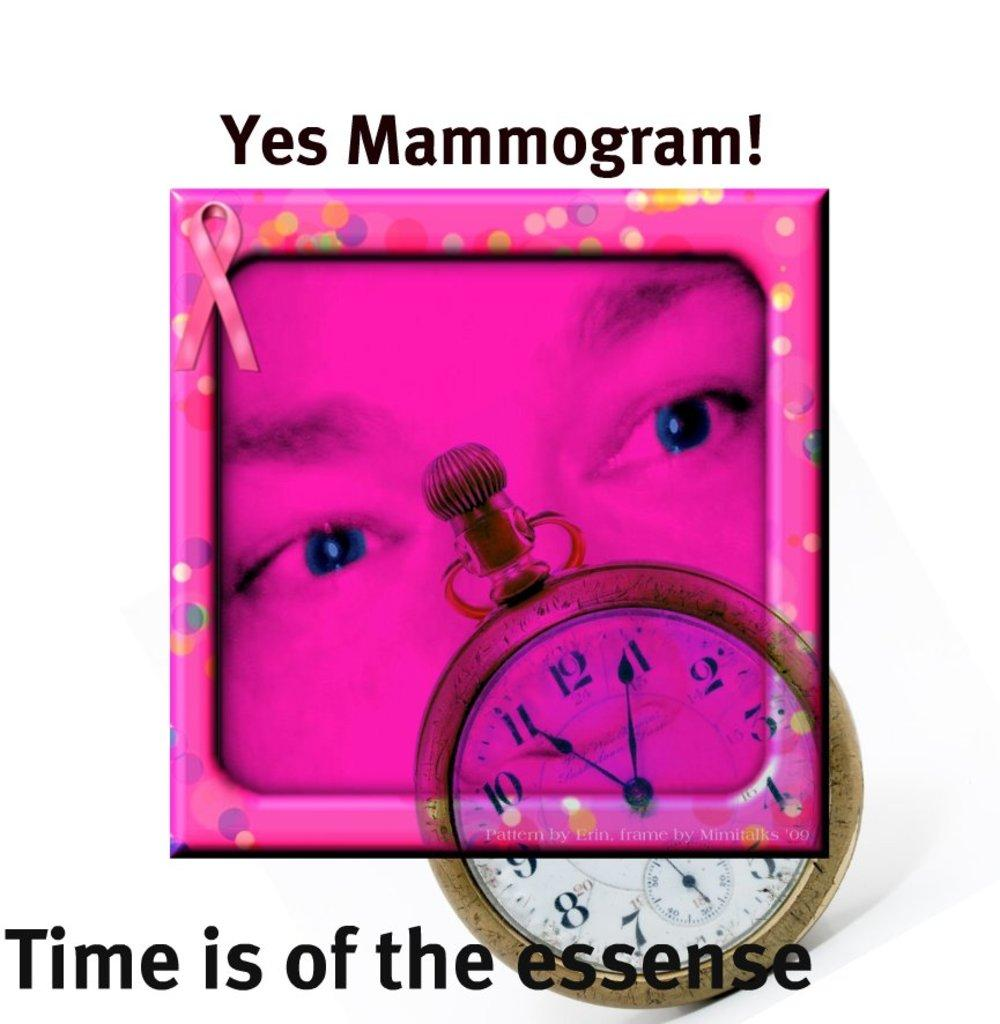<image>
Share a concise interpretation of the image provided. a sign saying Yes Mammogram with a pink face and watch on it 